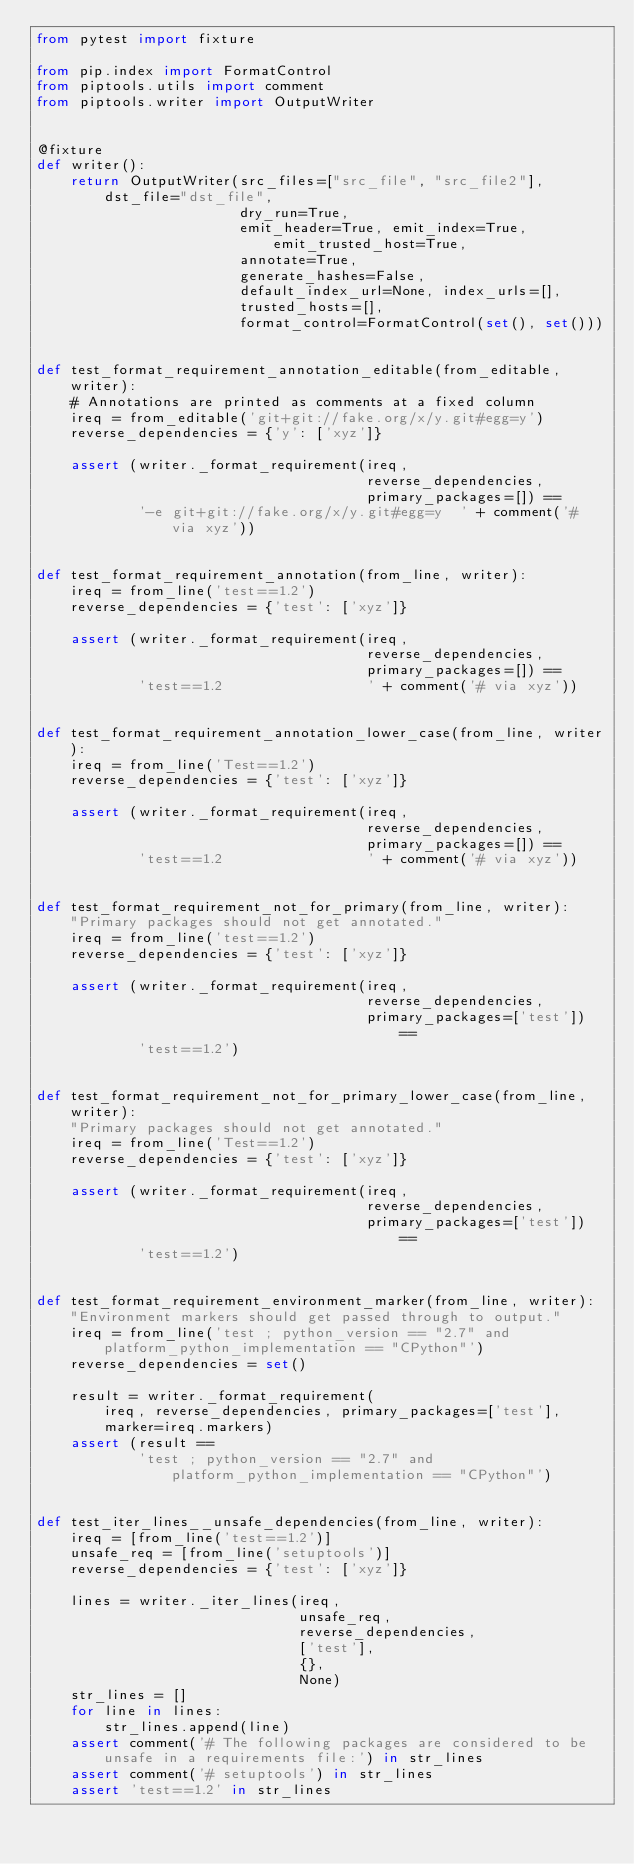Convert code to text. <code><loc_0><loc_0><loc_500><loc_500><_Python_>from pytest import fixture

from pip.index import FormatControl
from piptools.utils import comment
from piptools.writer import OutputWriter


@fixture
def writer():
    return OutputWriter(src_files=["src_file", "src_file2"], dst_file="dst_file",
                        dry_run=True,
                        emit_header=True, emit_index=True, emit_trusted_host=True,
                        annotate=True,
                        generate_hashes=False,
                        default_index_url=None, index_urls=[],
                        trusted_hosts=[],
                        format_control=FormatControl(set(), set()))


def test_format_requirement_annotation_editable(from_editable, writer):
    # Annotations are printed as comments at a fixed column
    ireq = from_editable('git+git://fake.org/x/y.git#egg=y')
    reverse_dependencies = {'y': ['xyz']}

    assert (writer._format_requirement(ireq,
                                       reverse_dependencies,
                                       primary_packages=[]) ==
            '-e git+git://fake.org/x/y.git#egg=y  ' + comment('# via xyz'))


def test_format_requirement_annotation(from_line, writer):
    ireq = from_line('test==1.2')
    reverse_dependencies = {'test': ['xyz']}

    assert (writer._format_requirement(ireq,
                                       reverse_dependencies,
                                       primary_packages=[]) ==
            'test==1.2                 ' + comment('# via xyz'))


def test_format_requirement_annotation_lower_case(from_line, writer):
    ireq = from_line('Test==1.2')
    reverse_dependencies = {'test': ['xyz']}

    assert (writer._format_requirement(ireq,
                                       reverse_dependencies,
                                       primary_packages=[]) ==
            'test==1.2                 ' + comment('# via xyz'))


def test_format_requirement_not_for_primary(from_line, writer):
    "Primary packages should not get annotated."
    ireq = from_line('test==1.2')
    reverse_dependencies = {'test': ['xyz']}

    assert (writer._format_requirement(ireq,
                                       reverse_dependencies,
                                       primary_packages=['test']) ==
            'test==1.2')


def test_format_requirement_not_for_primary_lower_case(from_line, writer):
    "Primary packages should not get annotated."
    ireq = from_line('Test==1.2')
    reverse_dependencies = {'test': ['xyz']}

    assert (writer._format_requirement(ireq,
                                       reverse_dependencies,
                                       primary_packages=['test']) ==
            'test==1.2')


def test_format_requirement_environment_marker(from_line, writer):
    "Environment markers should get passed through to output."
    ireq = from_line('test ; python_version == "2.7" and platform_python_implementation == "CPython"')
    reverse_dependencies = set()

    result = writer._format_requirement(
        ireq, reverse_dependencies, primary_packages=['test'],
        marker=ireq.markers)
    assert (result ==
            'test ; python_version == "2.7" and platform_python_implementation == "CPython"')


def test_iter_lines__unsafe_dependencies(from_line, writer):
    ireq = [from_line('test==1.2')]
    unsafe_req = [from_line('setuptools')]
    reverse_dependencies = {'test': ['xyz']}

    lines = writer._iter_lines(ireq,
                               unsafe_req,
                               reverse_dependencies,
                               ['test'],
                               {},
                               None)
    str_lines = []
    for line in lines:
        str_lines.append(line)
    assert comment('# The following packages are considered to be unsafe in a requirements file:') in str_lines
    assert comment('# setuptools') in str_lines
    assert 'test==1.2' in str_lines
</code> 